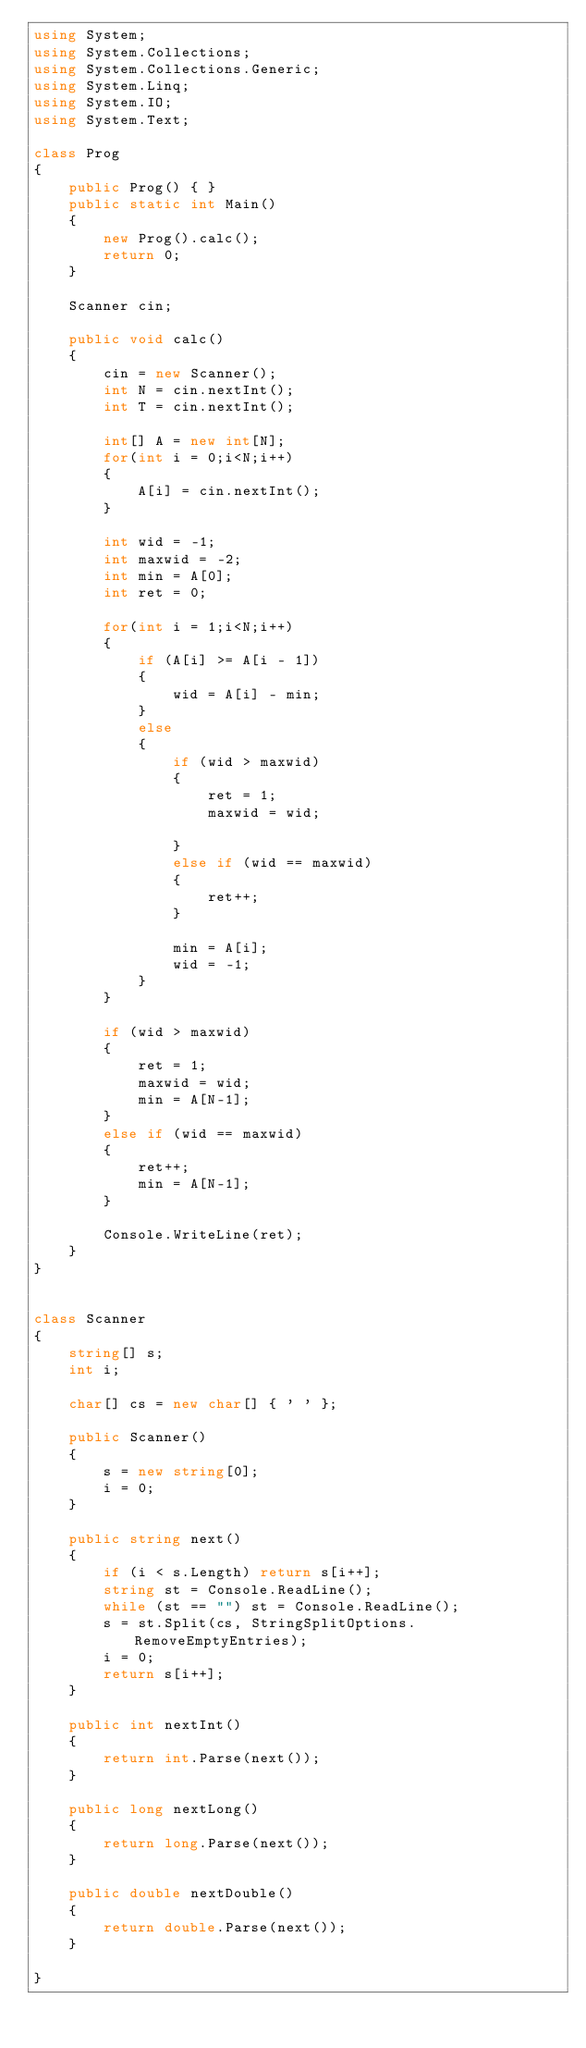Convert code to text. <code><loc_0><loc_0><loc_500><loc_500><_C#_>using System;
using System.Collections;
using System.Collections.Generic;
using System.Linq;
using System.IO;
using System.Text;

class Prog
{
    public Prog() { }
    public static int Main()
    {
        new Prog().calc();
        return 0;
    }

    Scanner cin;

    public void calc()
    {
        cin = new Scanner();
        int N = cin.nextInt();
        int T = cin.nextInt();

        int[] A = new int[N];
        for(int i = 0;i<N;i++)
        {
            A[i] = cin.nextInt();
        }

        int wid = -1;
        int maxwid = -2;
        int min = A[0];
        int ret = 0;

        for(int i = 1;i<N;i++)
        {
            if (A[i] >= A[i - 1])
            {
                wid = A[i] - min;
            }
            else
            {
                if (wid > maxwid)
                {
                    ret = 1;
                    maxwid = wid;

                }
                else if (wid == maxwid)
                {
                    ret++;
                }
                
                min = A[i];
                wid = -1;
            }
        }

        if (wid > maxwid)
        {
            ret = 1;
            maxwid = wid;
            min = A[N-1];
        }
        else if (wid == maxwid)
        {
            ret++;
            min = A[N-1];
        }

        Console.WriteLine(ret);
    }
}


class Scanner
{
    string[] s;
    int i;

    char[] cs = new char[] { ' ' };

    public Scanner()
    {
        s = new string[0];
        i = 0;
    }

    public string next()
    {
        if (i < s.Length) return s[i++];
        string st = Console.ReadLine();
        while (st == "") st = Console.ReadLine();
        s = st.Split(cs, StringSplitOptions.RemoveEmptyEntries);
        i = 0;
        return s[i++];
    }

    public int nextInt()
    {
        return int.Parse(next());
    }

    public long nextLong()
    {
        return long.Parse(next());
    }

    public double nextDouble()
    {
        return double.Parse(next());
    }

}</code> 